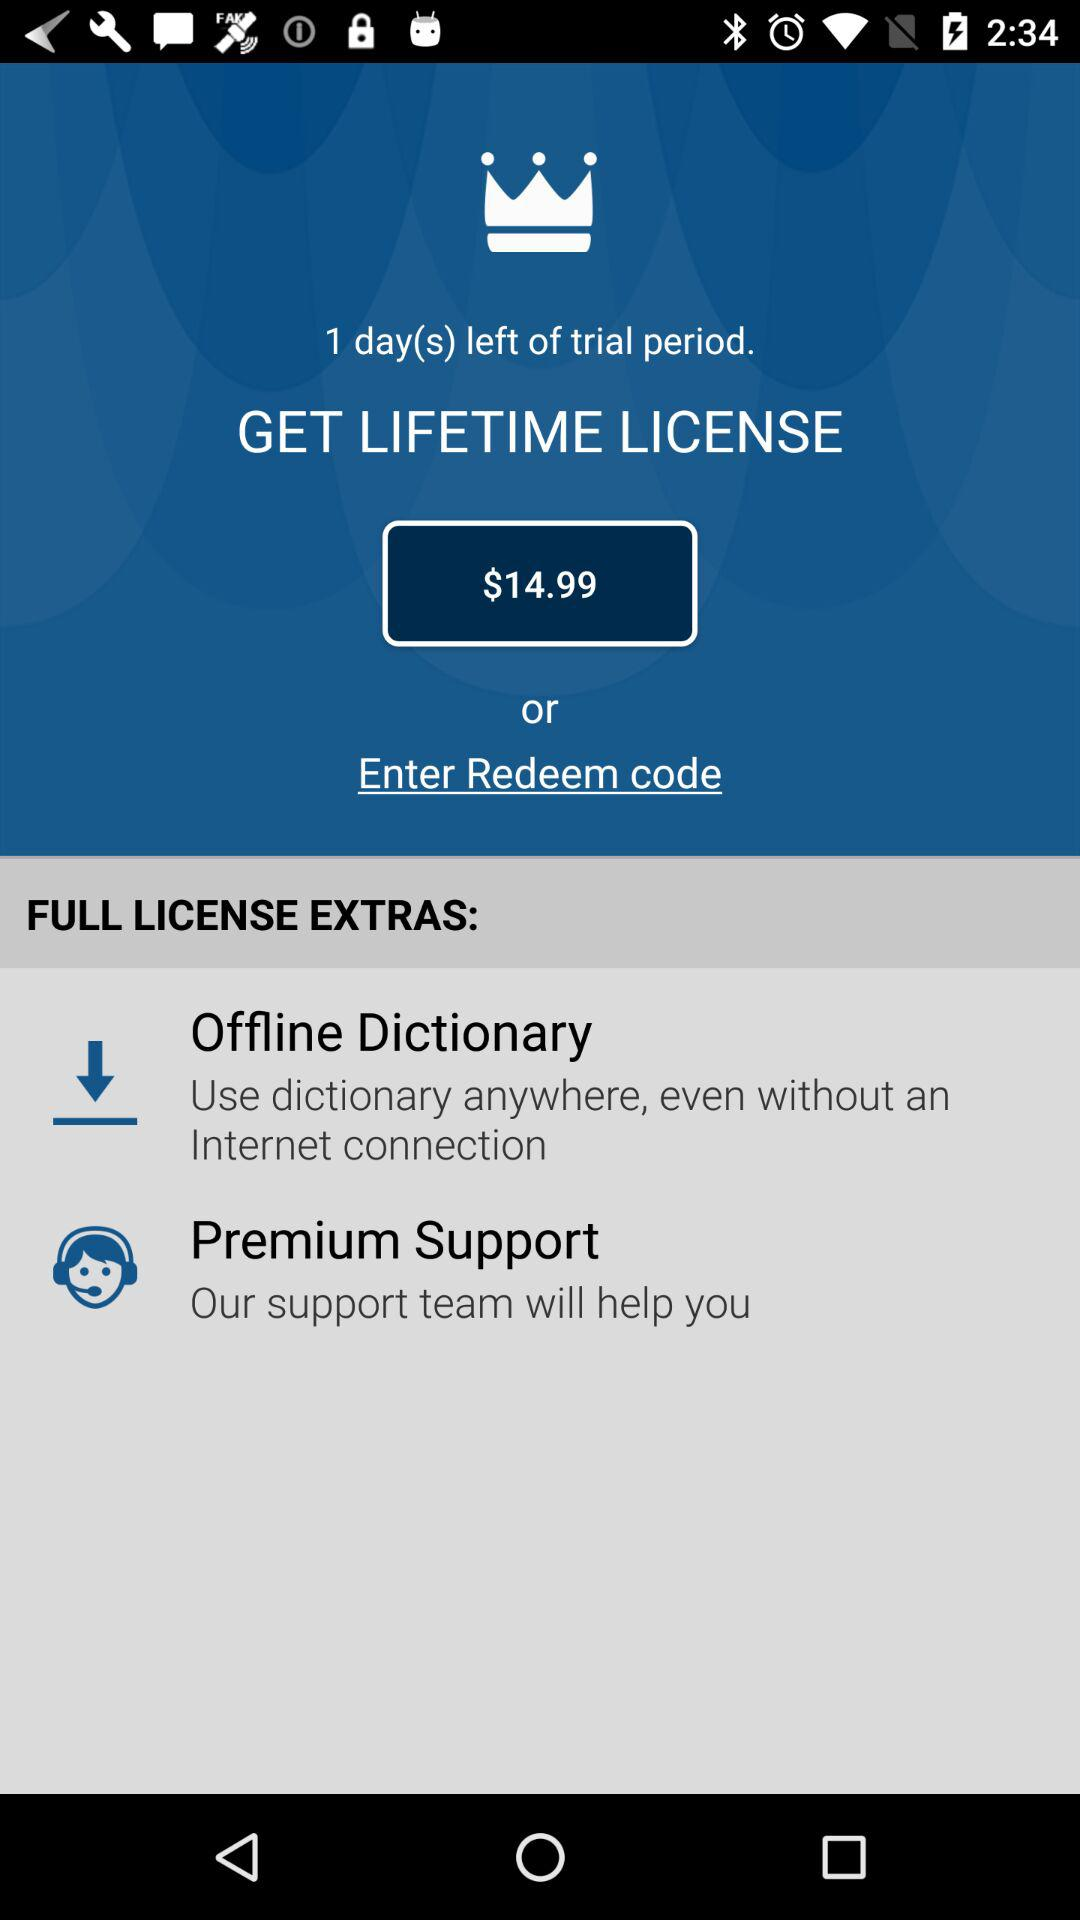How much more does the lifetime license cost than the one-day trial?
Answer the question using a single word or phrase. $14.99 